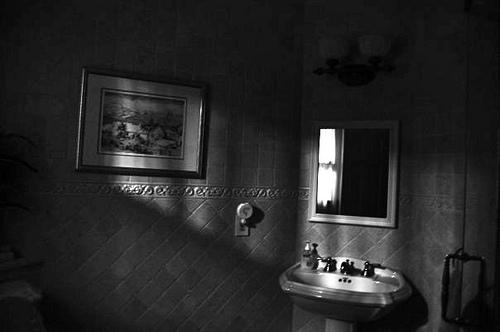What color is the hydrant?
Short answer required. No hydrant. Does the door handle turn?
Write a very short answer. No. Is the mirror cracked?
Give a very brief answer. No. Is the light on?
Write a very short answer. No. Why is the room dark?
Short answer required. Lights are off. Is it night time in the picture?
Quick response, please. No. Is there anyone at the sink?
Be succinct. No. How many sinks are in the bathroom?
Keep it brief. 1. 